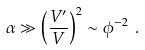<formula> <loc_0><loc_0><loc_500><loc_500>\alpha \gg \left ( { \frac { V ^ { \prime } } { V } } \right ) ^ { 2 } \sim \phi ^ { - 2 } \ .</formula> 